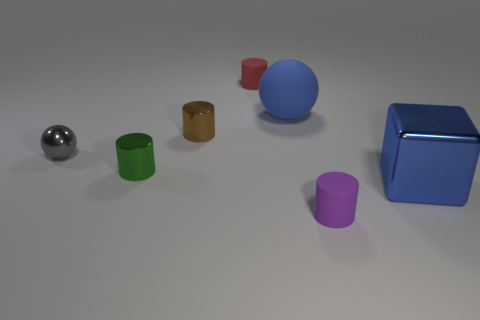If we imagine these objects had personalities, what kind of story could they be a part of? If imbued with personalities, these objects might be characters in a story about their adventures in Shape Land. The sphere could be a world traveler rolling from place to place, while the cylinders may be pillars of the community, known for their stability. The cube might be a wise elder, respected for its many sides and angles, each symbolizing a lesson learned in life. 